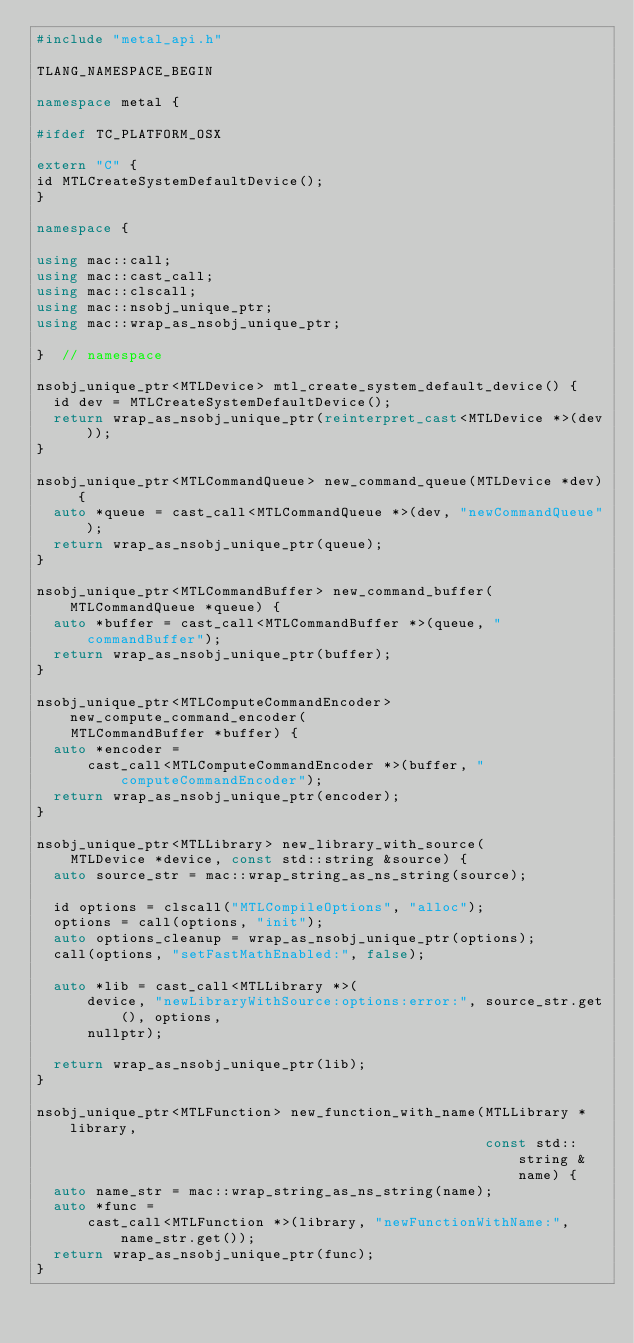Convert code to text. <code><loc_0><loc_0><loc_500><loc_500><_C++_>#include "metal_api.h"

TLANG_NAMESPACE_BEGIN

namespace metal {

#ifdef TC_PLATFORM_OSX

extern "C" {
id MTLCreateSystemDefaultDevice();
}

namespace {

using mac::call;
using mac::cast_call;
using mac::clscall;
using mac::nsobj_unique_ptr;
using mac::wrap_as_nsobj_unique_ptr;

}  // namespace

nsobj_unique_ptr<MTLDevice> mtl_create_system_default_device() {
  id dev = MTLCreateSystemDefaultDevice();
  return wrap_as_nsobj_unique_ptr(reinterpret_cast<MTLDevice *>(dev));
}

nsobj_unique_ptr<MTLCommandQueue> new_command_queue(MTLDevice *dev) {
  auto *queue = cast_call<MTLCommandQueue *>(dev, "newCommandQueue");
  return wrap_as_nsobj_unique_ptr(queue);
}

nsobj_unique_ptr<MTLCommandBuffer> new_command_buffer(MTLCommandQueue *queue) {
  auto *buffer = cast_call<MTLCommandBuffer *>(queue, "commandBuffer");
  return wrap_as_nsobj_unique_ptr(buffer);
}

nsobj_unique_ptr<MTLComputeCommandEncoder> new_compute_command_encoder(
    MTLCommandBuffer *buffer) {
  auto *encoder =
      cast_call<MTLComputeCommandEncoder *>(buffer, "computeCommandEncoder");
  return wrap_as_nsobj_unique_ptr(encoder);
}

nsobj_unique_ptr<MTLLibrary> new_library_with_source(
    MTLDevice *device, const std::string &source) {
  auto source_str = mac::wrap_string_as_ns_string(source);

  id options = clscall("MTLCompileOptions", "alloc");
  options = call(options, "init");
  auto options_cleanup = wrap_as_nsobj_unique_ptr(options);
  call(options, "setFastMathEnabled:", false);

  auto *lib = cast_call<MTLLibrary *>(
      device, "newLibraryWithSource:options:error:", source_str.get(), options,
      nullptr);

  return wrap_as_nsobj_unique_ptr(lib);
}

nsobj_unique_ptr<MTLFunction> new_function_with_name(MTLLibrary *library,
                                                     const std::string &name) {
  auto name_str = mac::wrap_string_as_ns_string(name);
  auto *func =
      cast_call<MTLFunction *>(library, "newFunctionWithName:", name_str.get());
  return wrap_as_nsobj_unique_ptr(func);
}
</code> 